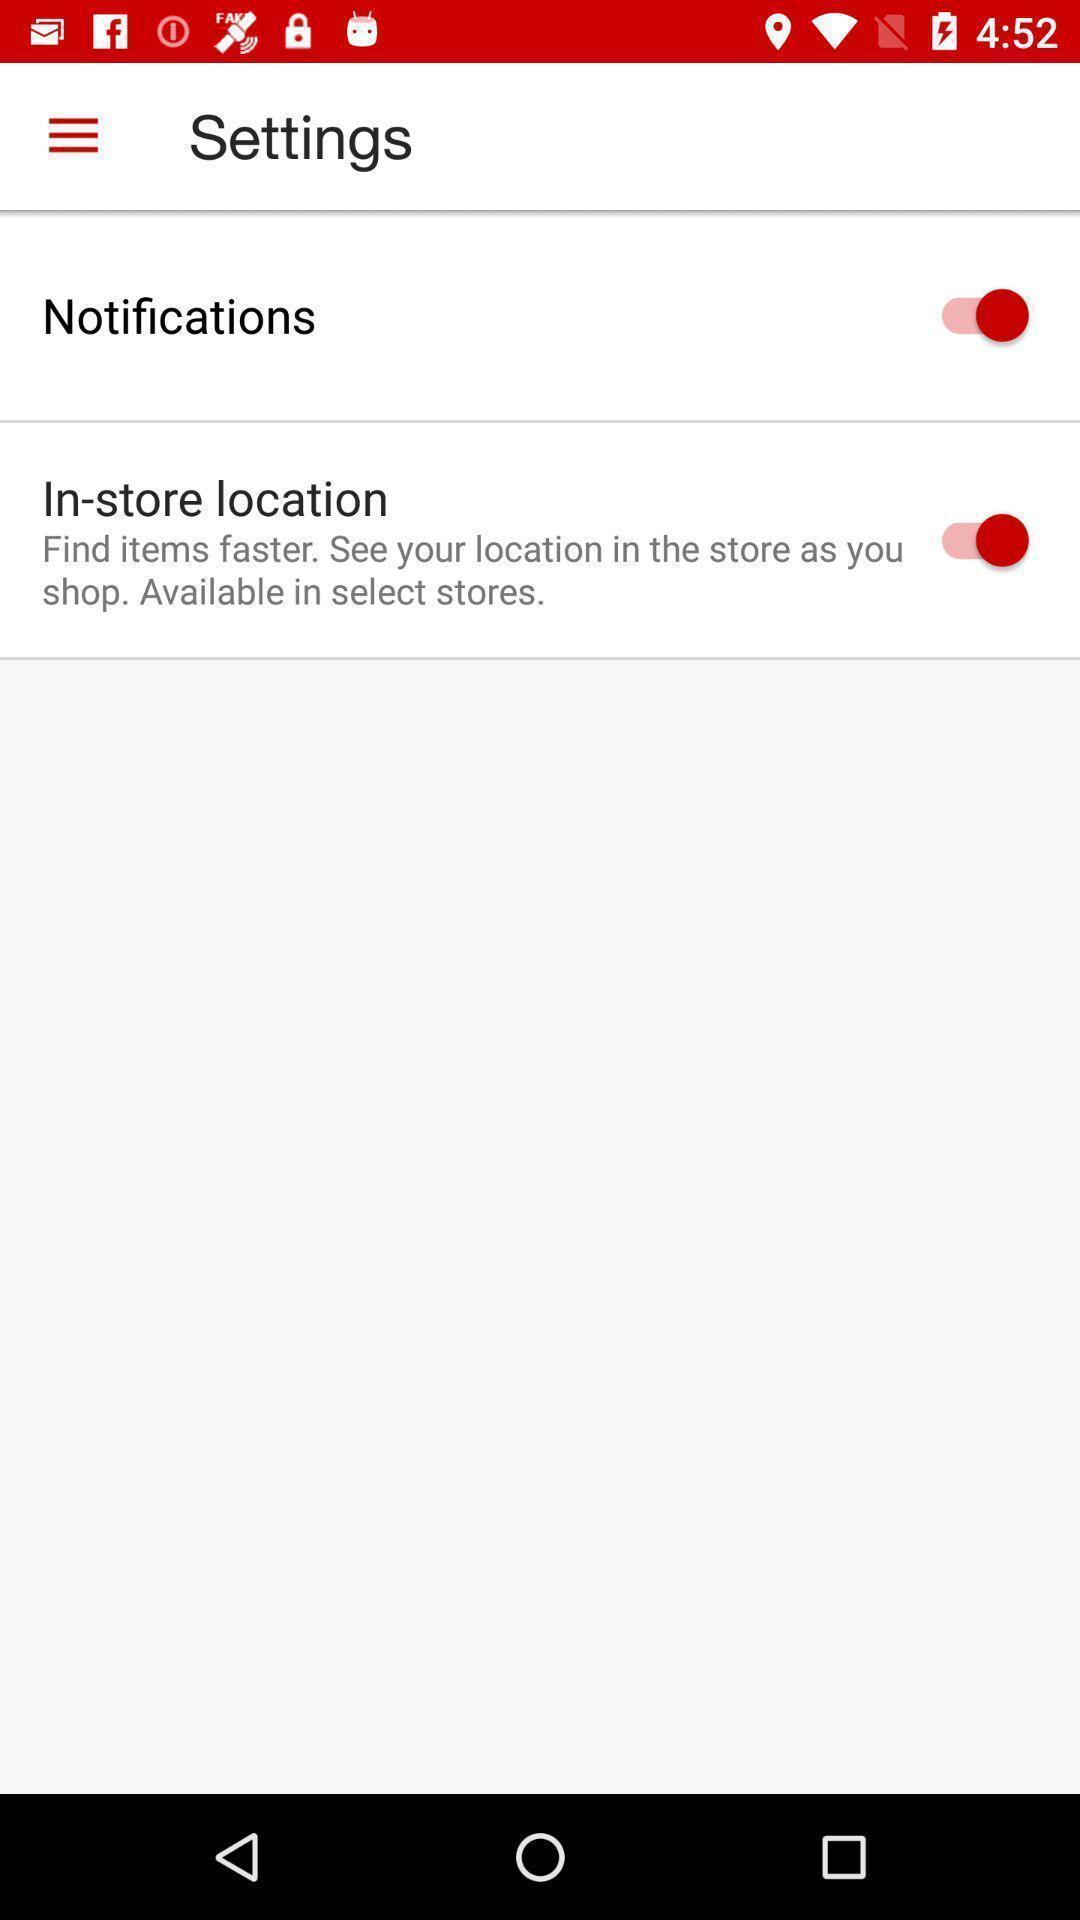Summarize the main components in this picture. Settings page with options. 